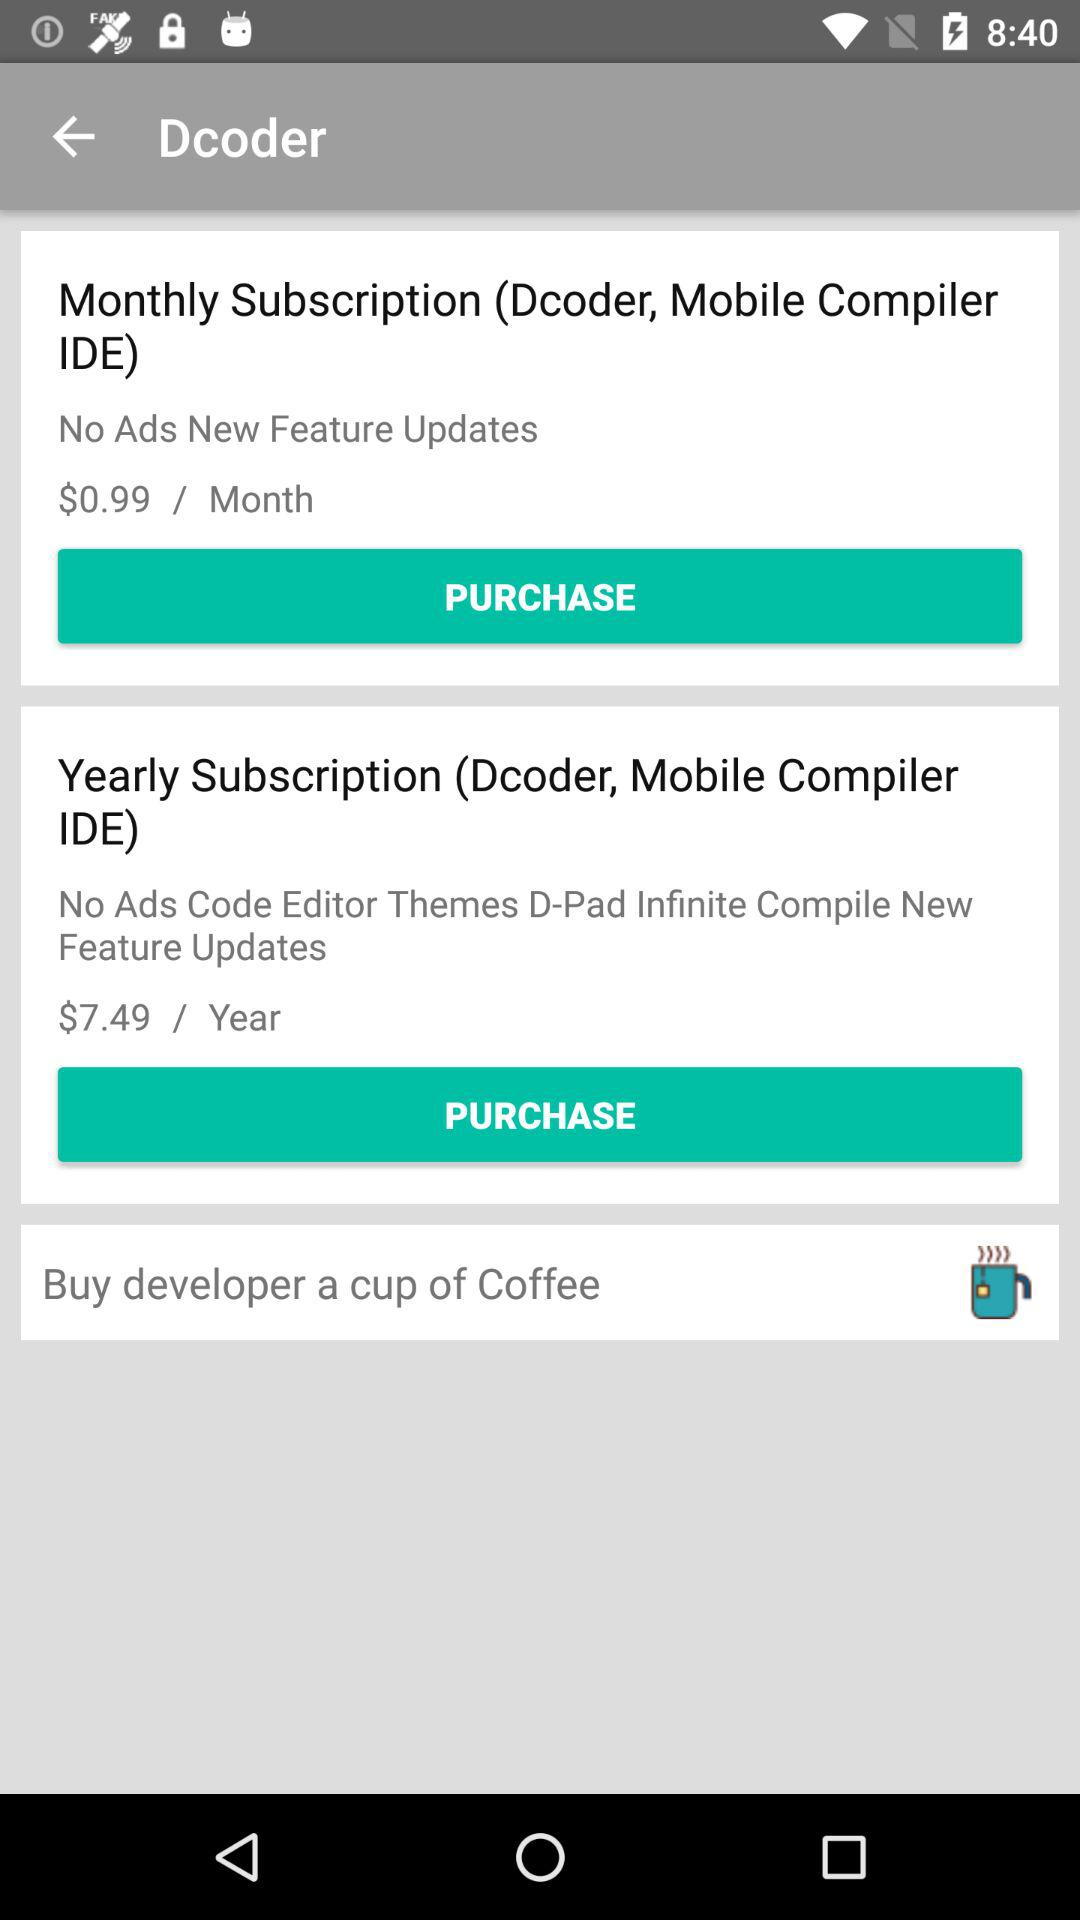What is the price of the monthly subscription package? The price is $0.99/month. 